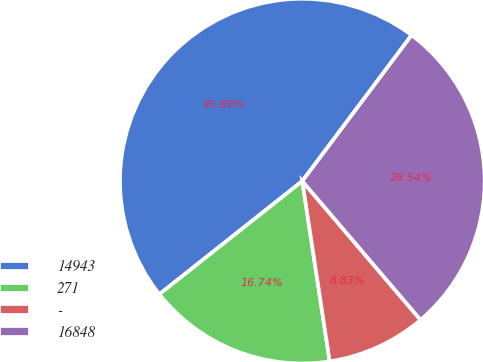Convert chart to OTSL. <chart><loc_0><loc_0><loc_500><loc_500><pie_chart><fcel>14943<fcel>271<fcel>-<fcel>16848<nl><fcel>45.89%<fcel>16.74%<fcel>8.83%<fcel>28.54%<nl></chart> 